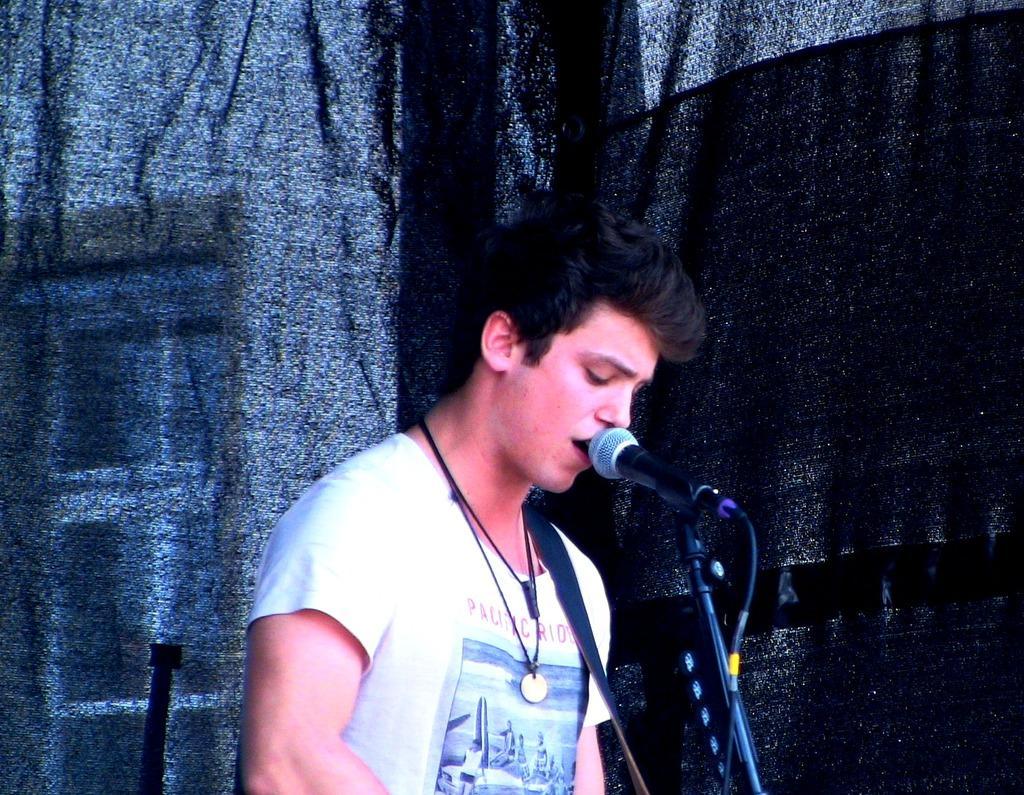Can you describe this image briefly? In this image, we can see a person on the dark background. This person is wearing clothes. There is a mic at the bottom of the image. 